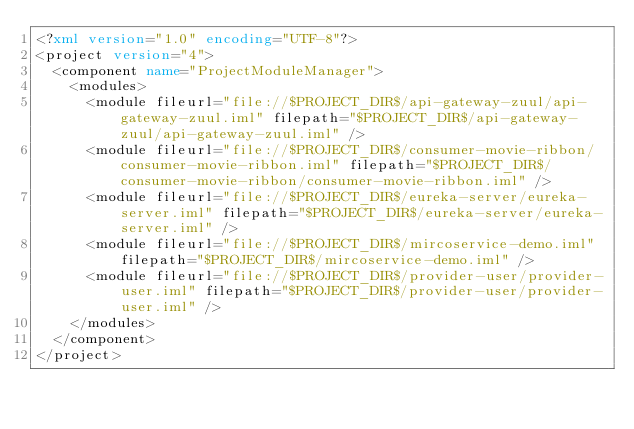<code> <loc_0><loc_0><loc_500><loc_500><_XML_><?xml version="1.0" encoding="UTF-8"?>
<project version="4">
  <component name="ProjectModuleManager">
    <modules>
      <module fileurl="file://$PROJECT_DIR$/api-gateway-zuul/api-gateway-zuul.iml" filepath="$PROJECT_DIR$/api-gateway-zuul/api-gateway-zuul.iml" />
      <module fileurl="file://$PROJECT_DIR$/consumer-movie-ribbon/consumer-movie-ribbon.iml" filepath="$PROJECT_DIR$/consumer-movie-ribbon/consumer-movie-ribbon.iml" />
      <module fileurl="file://$PROJECT_DIR$/eureka-server/eureka-server.iml" filepath="$PROJECT_DIR$/eureka-server/eureka-server.iml" />
      <module fileurl="file://$PROJECT_DIR$/mircoservice-demo.iml" filepath="$PROJECT_DIR$/mircoservice-demo.iml" />
      <module fileurl="file://$PROJECT_DIR$/provider-user/provider-user.iml" filepath="$PROJECT_DIR$/provider-user/provider-user.iml" />
    </modules>
  </component>
</project></code> 